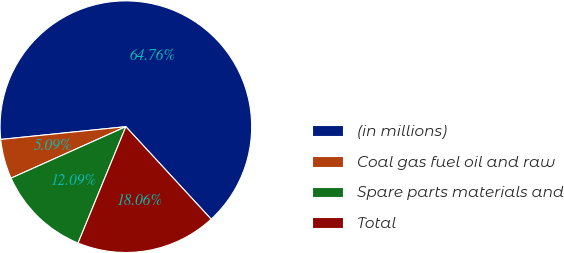Convert chart. <chart><loc_0><loc_0><loc_500><loc_500><pie_chart><fcel>(in millions)<fcel>Coal gas fuel oil and raw<fcel>Spare parts materials and<fcel>Total<nl><fcel>64.76%<fcel>5.09%<fcel>12.09%<fcel>18.06%<nl></chart> 